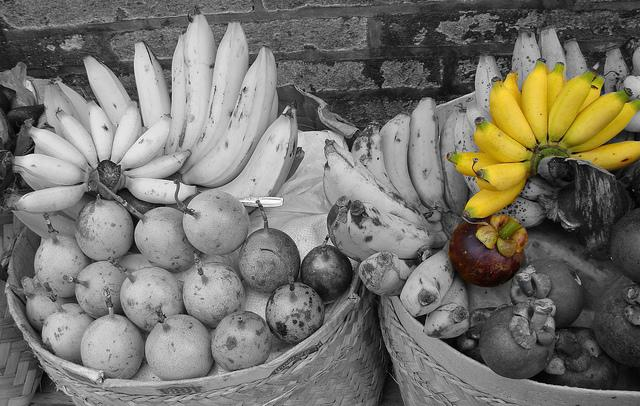Where is this produce located?

Choices:
A) market
B) store
C) refrigerator
D) driveway market 